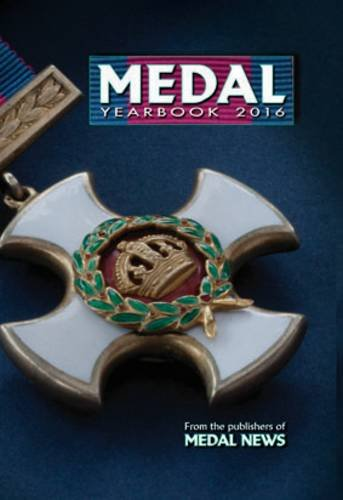What type of book is this? This book is a reference guide specifically for collectors of medals, detailing various medals and their historical significance. 